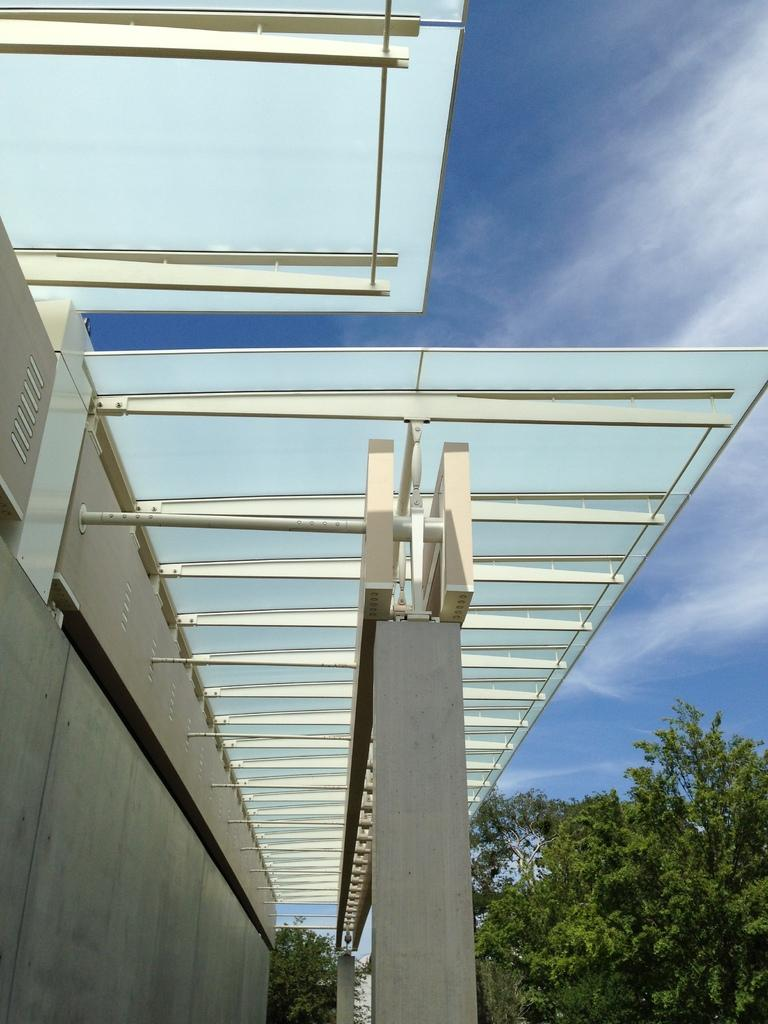What is the color of the building in the image? The building in the image is gray. What can be seen in the background of the image? There are trees in the background of the image, and they are green. What colors are visible in the sky in the image? The sky is visible in the image, and it is blue and white. What type of structure is present in the image? There is a glass shed in the image. What type of oil is being used to lubricate the fan in the image? There is no fan or oil present in the image. 